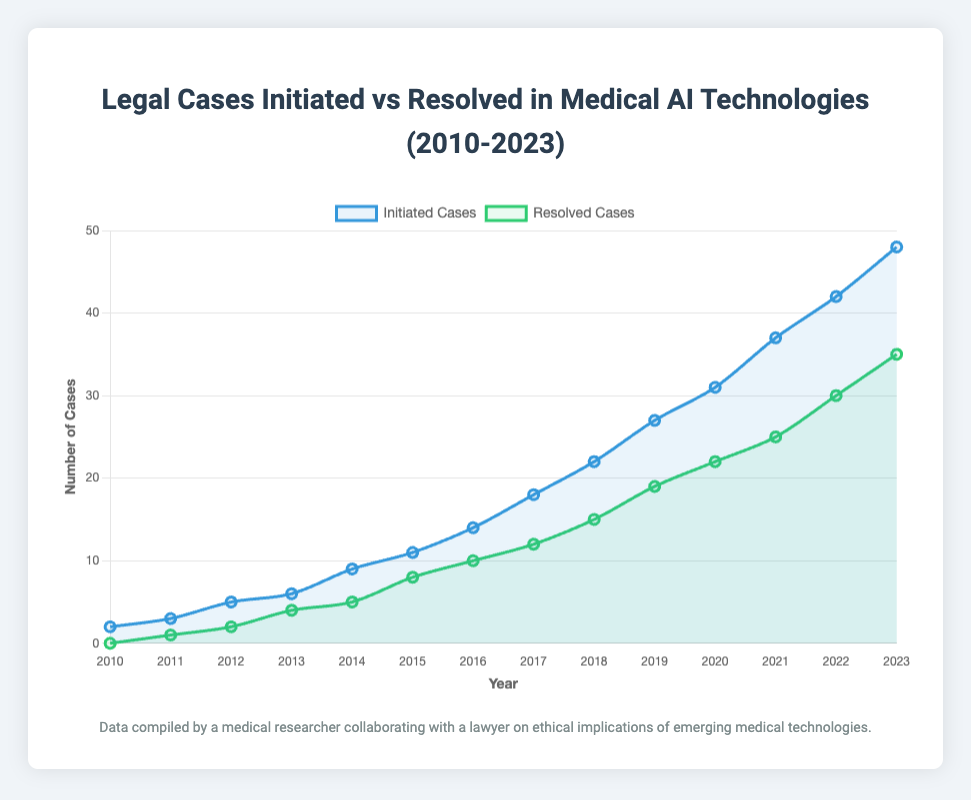What's the difference between initiated and resolved cases in 2023? To find the difference, subtract the number of resolved cases from the number of initiated cases in 2023. Thus, 48 - 35 = 13
Answer: 13 In which year were there more initiated cases than resolved cases? By looking at the plot, it can be observed that in each year from 2010 to 2023, the number of initiated cases consistently exceeds the number of resolved cases.
Answer: Every year from 2010 to 2023 How many cases were initiated and resolved in total from 2010 to 2023? Sum all the initiated cases and all the resolved cases from 2010 to 2023. Summing the initiated cases gives 275 and summing the resolved cases gives 188.
Answer: Initiated: 275, Resolved: 188 What is the average number of initiated cases per year between 2010 and 2023? To calculate the average, sum the total number of initiated cases from 2010 to 2023 which is 275 and then divide by the number of years which is 14. So, 275 / 14 = approximately 19.64
Answer: 19.64 In which year did the number of resolved cases first exceed 10? By examining the figure, the number of resolved cases first exceeded 10 in the year 2016.
Answer: 2016 Which color represents the resolved cases in the plot? Looking at the visual representation, the resolved cases are depicted by the green line.
Answer: Green What is the trend observed in the number of initiated cases from 2010 to 2023? The visual representation shows an upward trend in the number of initiated cases over the years, indicating a steady increase.
Answer: Upward trend How many more cases were initiated than resolved in 2018? To determine the difference for the year 2018, subtract the resolved cases from the initiated cases, i.e., 22 - 15 = 7
Answer: 7 By how much did the number of resolved cases increase from 2014 to 2015? Subtract the number of resolved cases in 2014 from the number of resolved cases in 2015. So, 8 - 5 = 3
Answer: 3 